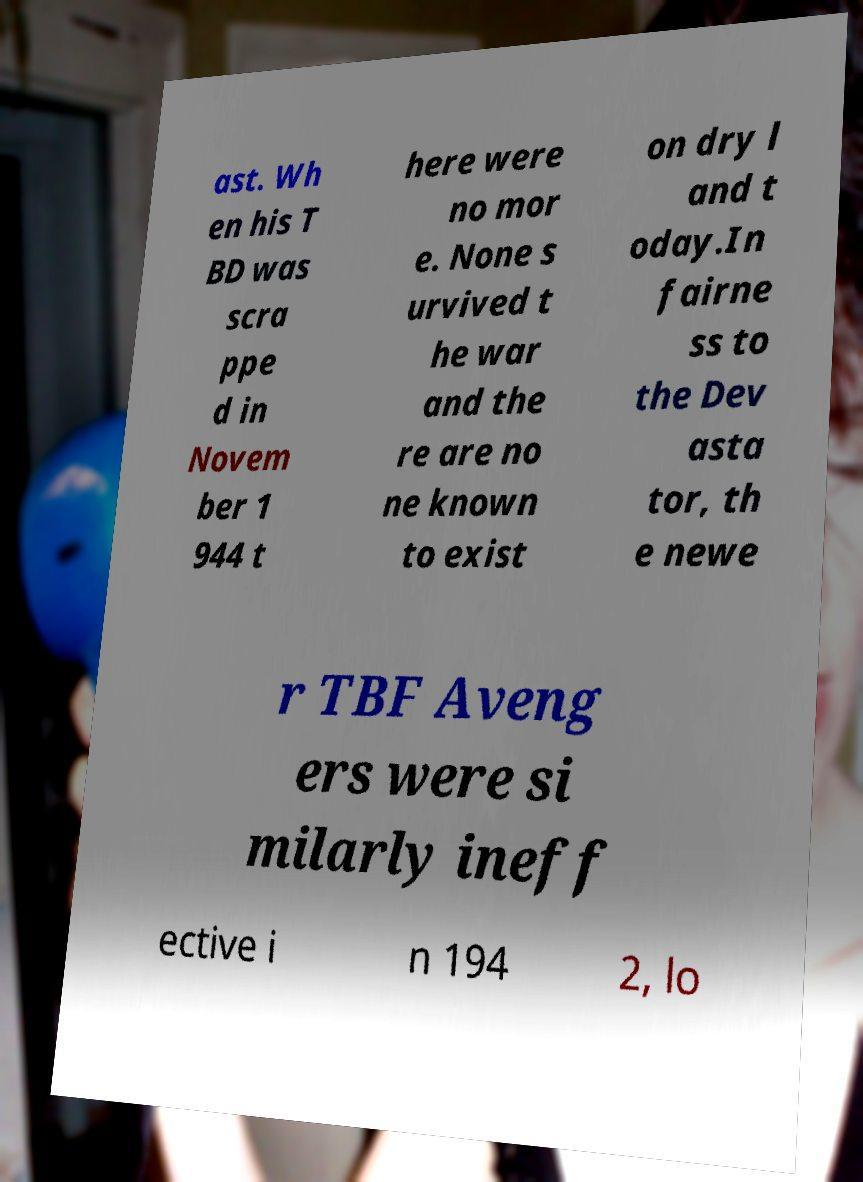I need the written content from this picture converted into text. Can you do that? ast. Wh en his T BD was scra ppe d in Novem ber 1 944 t here were no mor e. None s urvived t he war and the re are no ne known to exist on dry l and t oday.In fairne ss to the Dev asta tor, th e newe r TBF Aveng ers were si milarly ineff ective i n 194 2, lo 